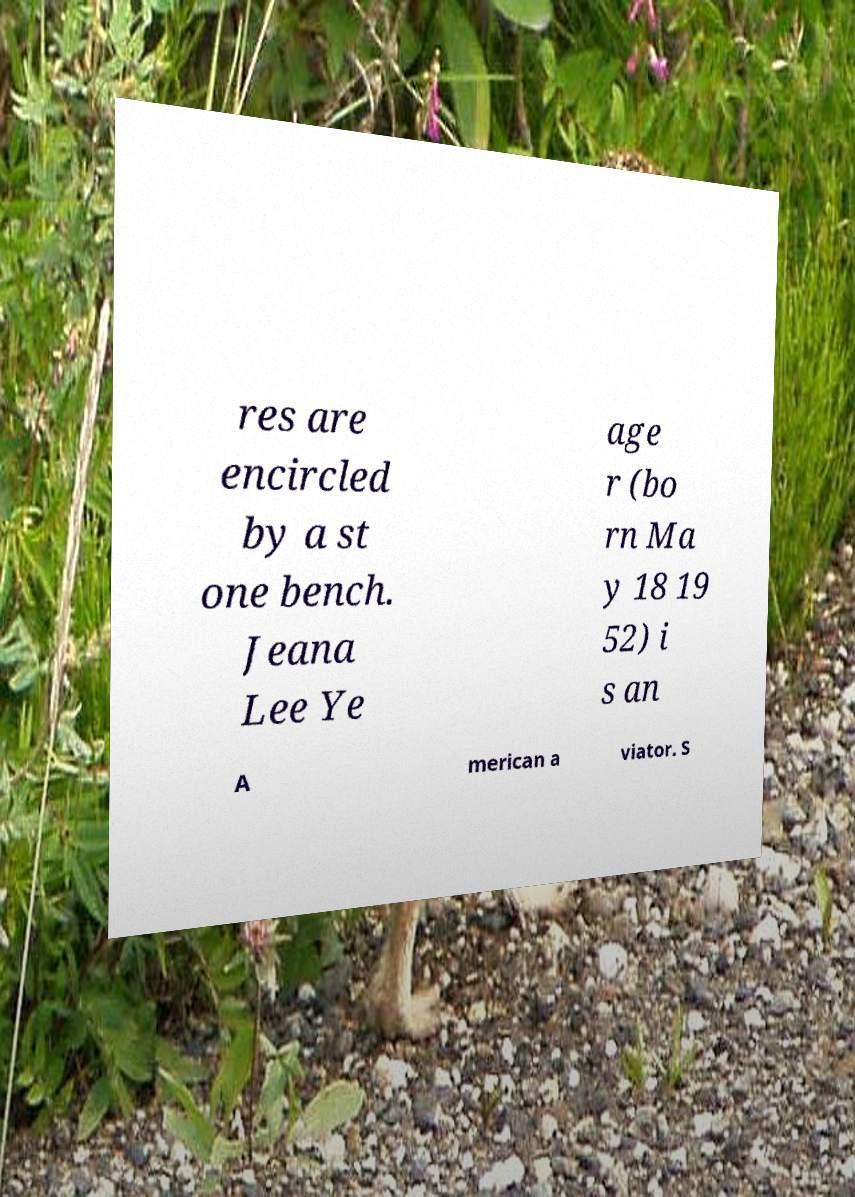Can you read and provide the text displayed in the image?This photo seems to have some interesting text. Can you extract and type it out for me? res are encircled by a st one bench. Jeana Lee Ye age r (bo rn Ma y 18 19 52) i s an A merican a viator. S 